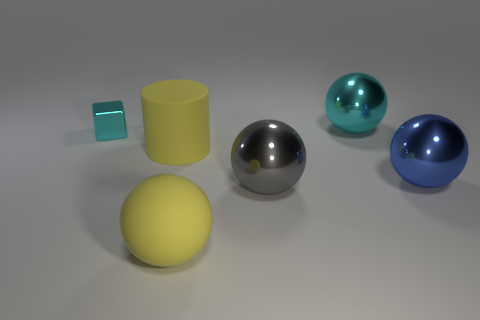What can you say about the colors in the image? The image features a relatively muted color palette with primary focus on cooler tones. The most vibrant color is the blue of the larger sphere, which provides a stark contrast to its surroundings. The yellow of the sphere in the foreground adds a pop of warm color that draws the eye. The rest of the objects are in neutral colors, with the metallic spheres reflecting the white background, which helps them blend into the scene while still providing visual interest through their shininess. 